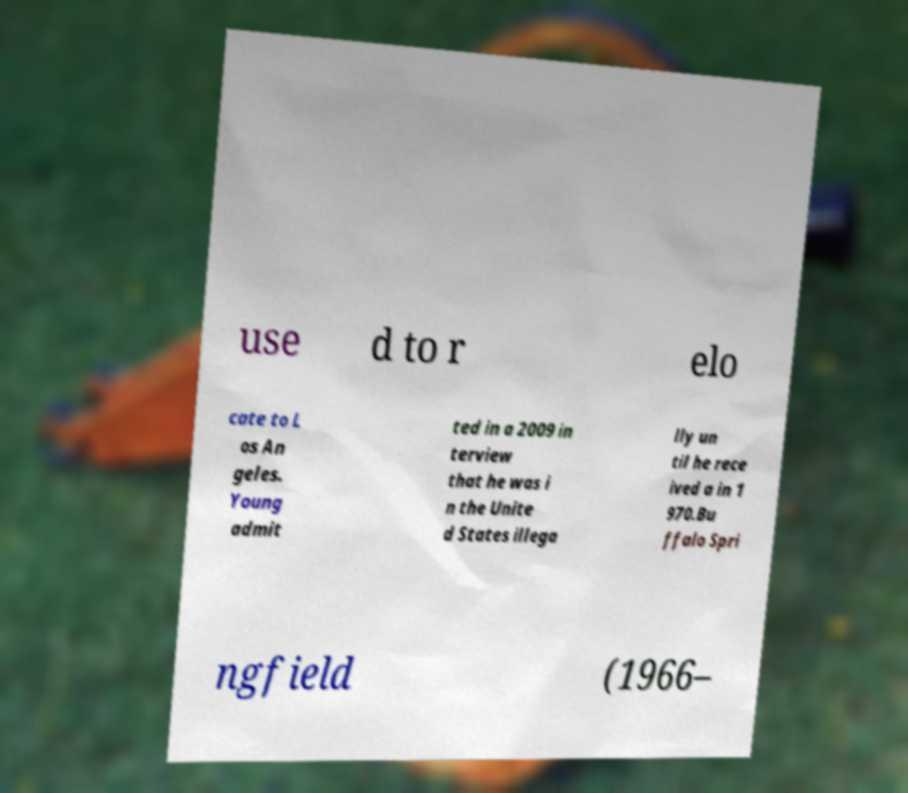What messages or text are displayed in this image? I need them in a readable, typed format. use d to r elo cate to L os An geles. Young admit ted in a 2009 in terview that he was i n the Unite d States illega lly un til he rece ived a in 1 970.Bu ffalo Spri ngfield (1966– 